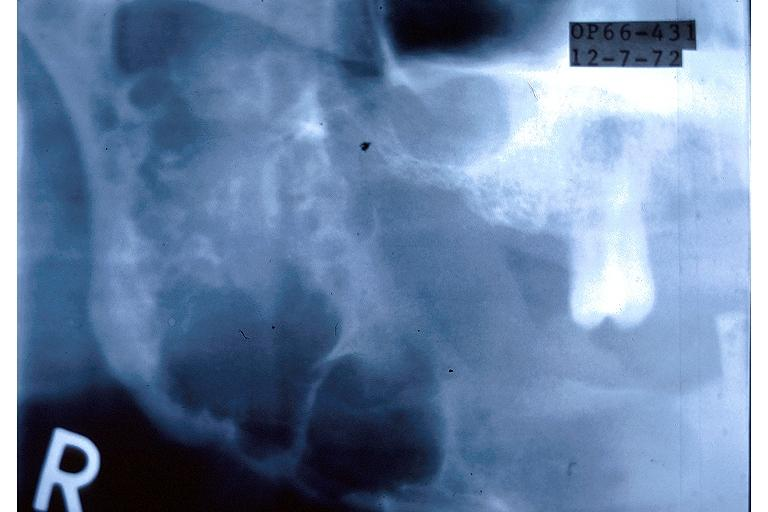what is present?
Answer the question using a single word or phrase. Oral 